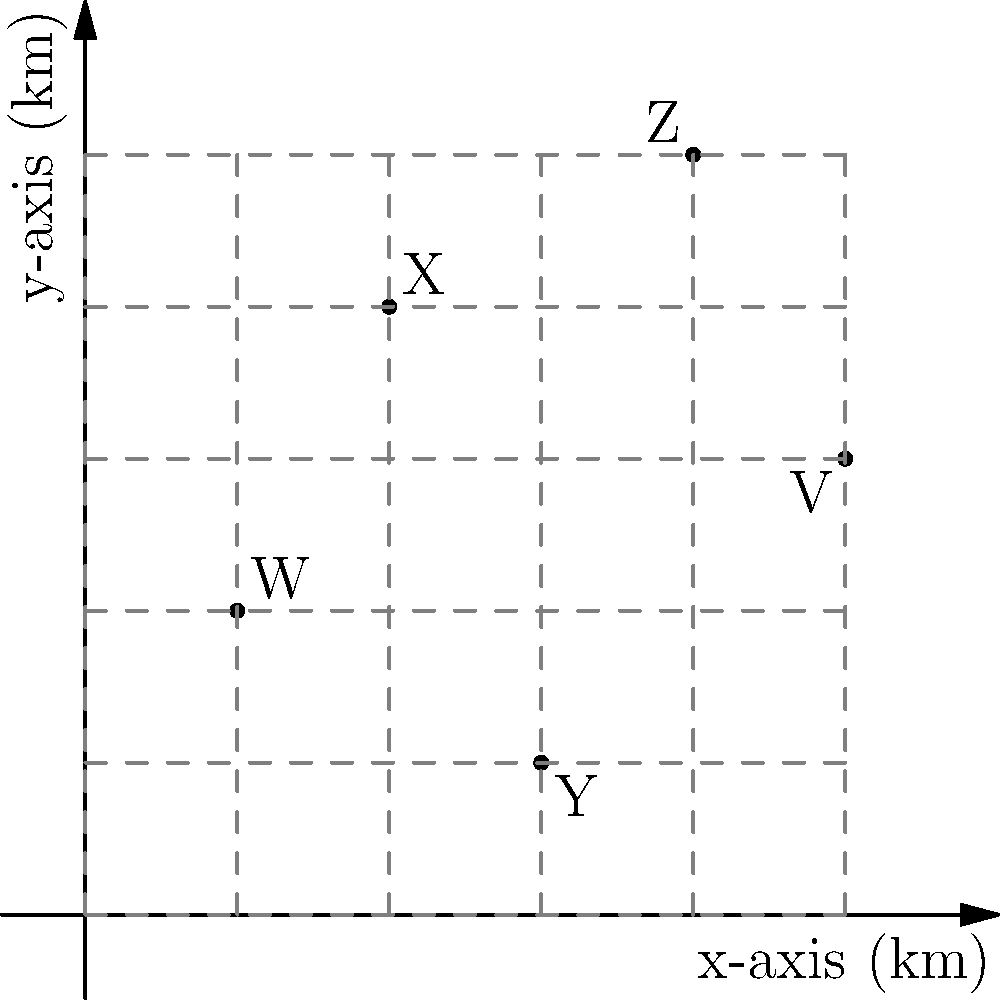As a livestock owner, you've plotted recent predator sightings on a coordinate grid, where each unit represents 1 km. Points W, X, Y, Z, and V represent different sighting locations. Which two sighting locations are closest to each other, potentially indicating a high-risk area for your livestock? To find the two closest sighting locations, we need to calculate the distances between all pairs of points using the distance formula: $d = \sqrt{(x_2-x_1)^2 + (y_2-y_1)^2}$

1. Calculate distances:
   WX: $\sqrt{(2-1)^2 + (4-2)^2} = \sqrt{5} \approx 2.24$ km
   WY: $\sqrt{(3-1)^2 + (1-2)^2} = \sqrt{5} \approx 2.24$ km
   WZ: $\sqrt{(4-1)^2 + (5-2)^2} = \sqrt{34} \approx 5.83$ km
   WV: $\sqrt{(5-1)^2 + (3-2)^2} = \sqrt{17} \approx 4.12$ km
   XY: $\sqrt{(3-2)^2 + (1-4)^2} = \sqrt{10} \approx 3.16$ km
   XZ: $\sqrt{(4-2)^2 + (5-4)^2} = \sqrt{5} \approx 2.24$ km
   XV: $\sqrt{(5-2)^2 + (3-4)^2} = \sqrt{10} \approx 3.16$ km
   YZ: $\sqrt{(4-3)^2 + (5-1)^2} = \sqrt{17} \approx 4.12$ km
   YV: $\sqrt{(5-3)^2 + (3-1)^2} = \sqrt{8} \approx 2.83$ km
   ZV: $\sqrt{(5-4)^2 + (3-5)^2} = \sqrt{5} \approx 2.24$ km

2. Identify the shortest distance:
   The shortest distance is 2.24 km, which occurs between several pairs: WX, WY, XZ, and ZV.

3. Among these pairs, WX has the lowest x-coordinates, making it the westernmost pair.

Therefore, W and X are the closest sighting locations, potentially indicating a high-risk area for livestock.
Answer: W and X 